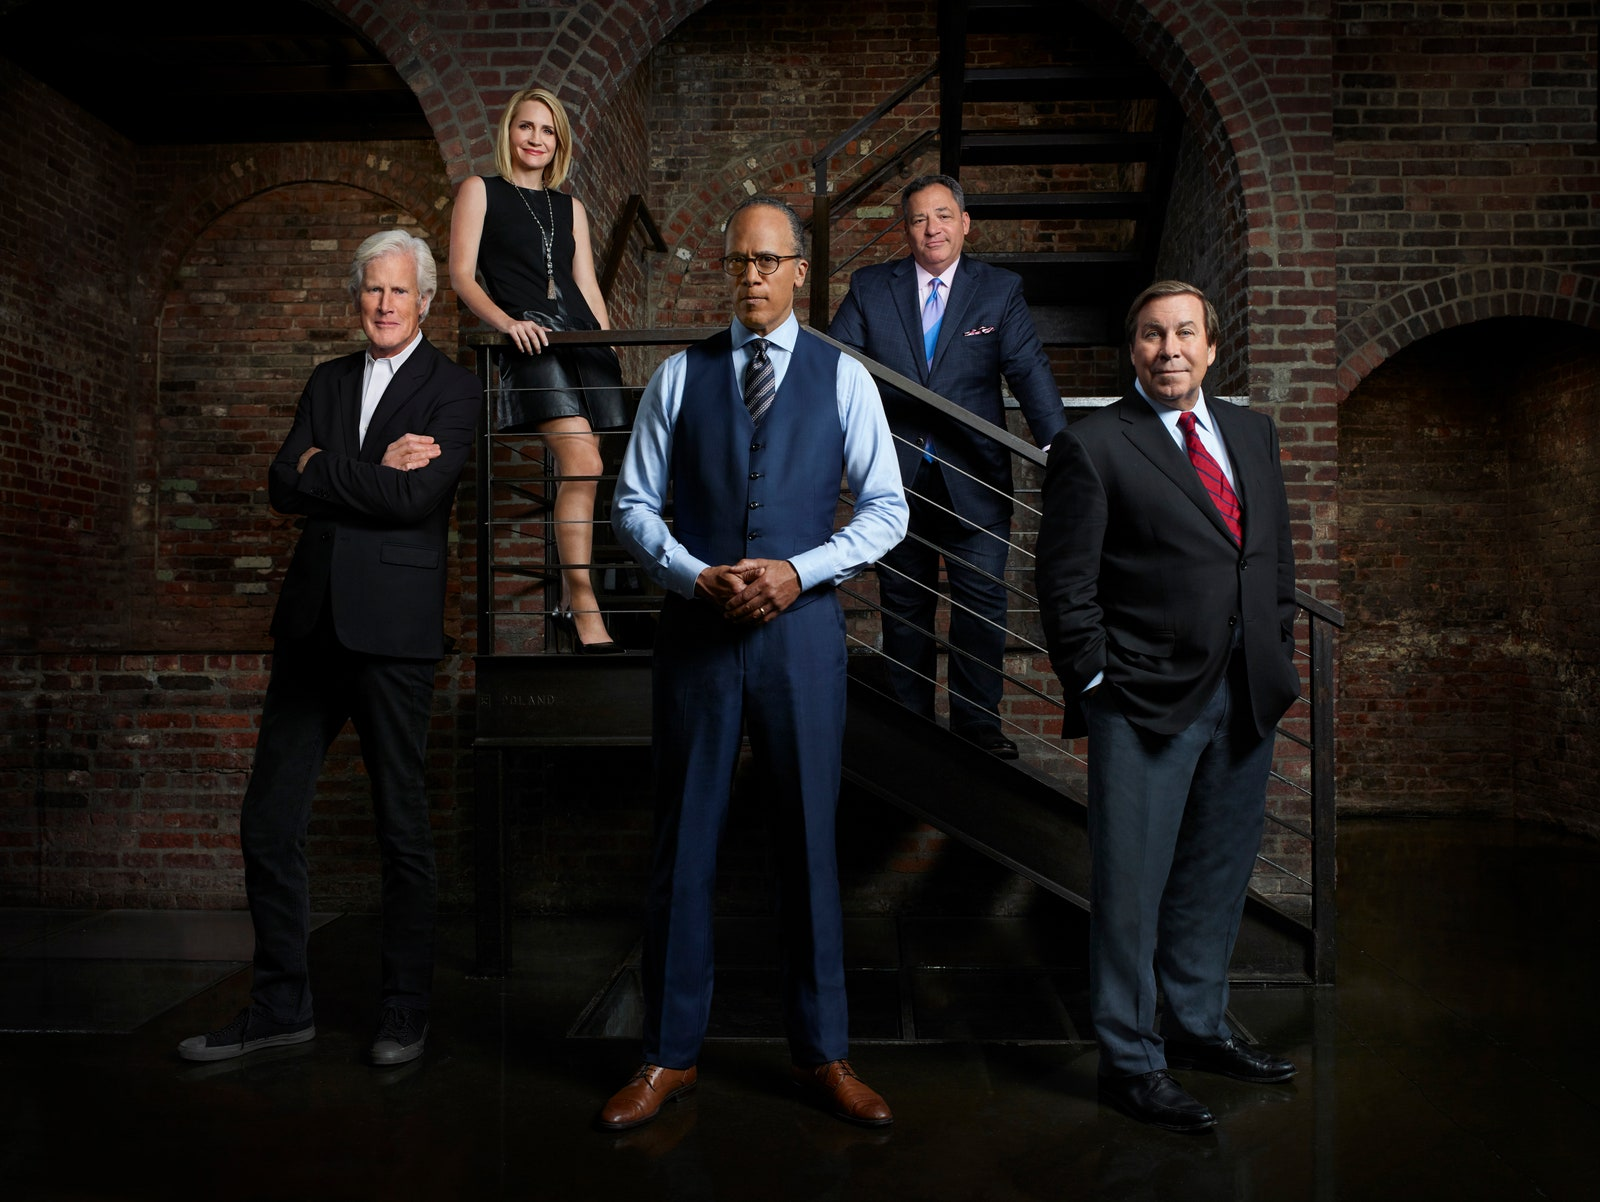If these individuals were superheroes, what would their powers and team dynamics be like? As superheroes, this team would be a formidable force. The central figure, with a power of superhuman intellect and leadership, would coordinate their actions with precision. The woman might possess the power of telekinesis, able to manipulate objects and protect her teammates. The man in the black suit could have the ability to become invisible, perfect for reconnaissance and stealth missions. The man in glasses might wield advanced technological capabilities, controlling machines and gadgets. Lastly, the man in the blue suit could exhibit superhuman strength and durability, making him the frontline defender in battles. Together, their dynamics would be based on trust, strategic planning, and leveraging each other’s unique abilities to maintain peace and justice. 